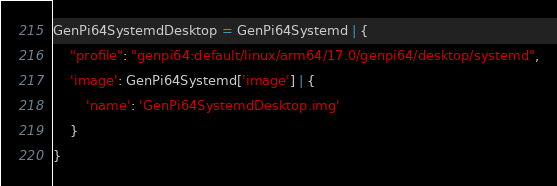<code> <loc_0><loc_0><loc_500><loc_500><_Python_>GenPi64SystemdDesktop = GenPi64Systemd | {
    "profile": "genpi64:default/linux/arm64/17.0/genpi64/desktop/systemd",
    'image': GenPi64Systemd['image'] | {
        'name': 'GenPi64SystemdDesktop.img'
    }
}
</code> 